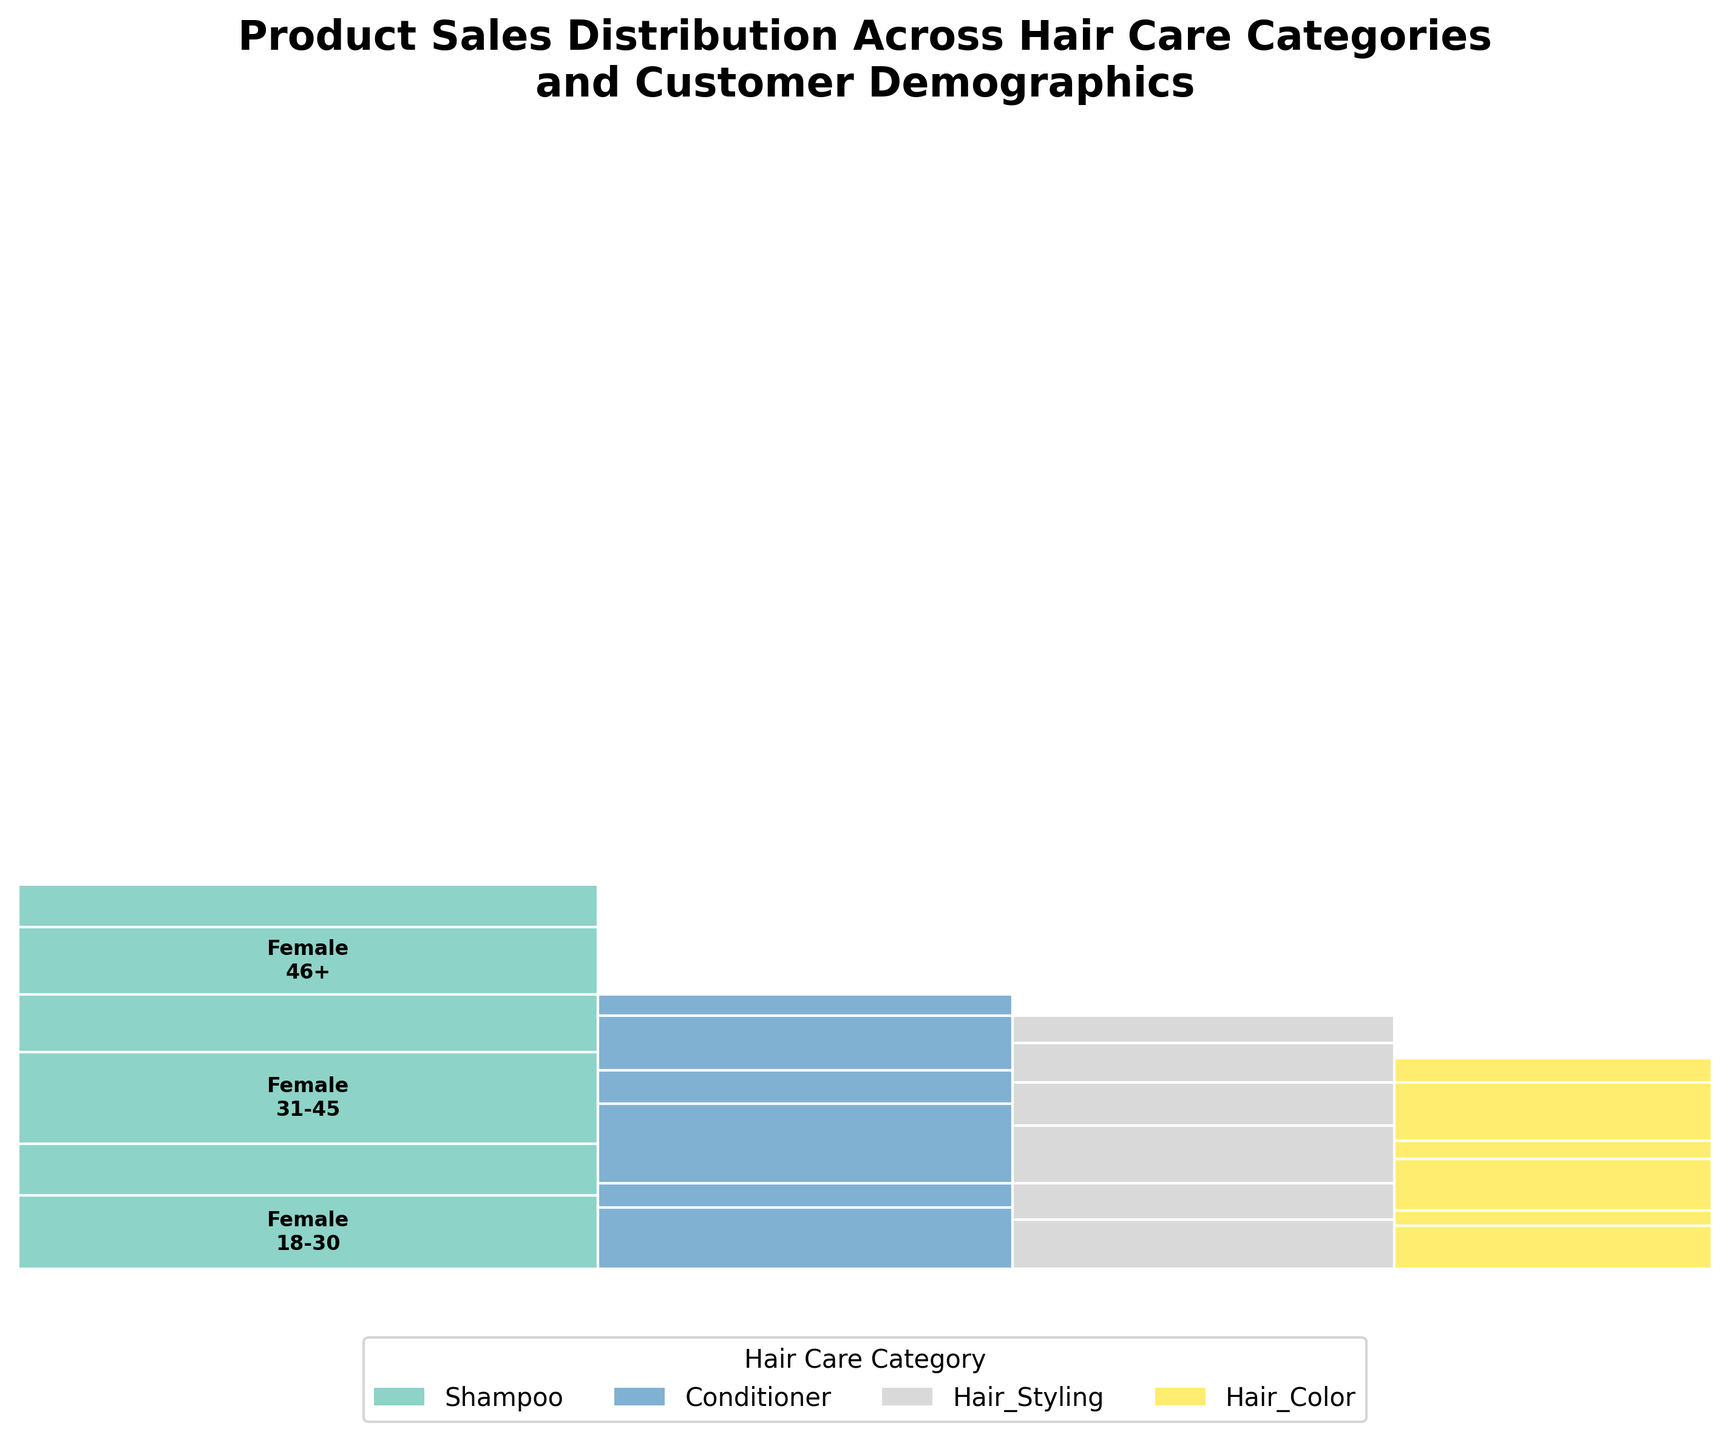What is the title of the plot? The title of the plot is located at the top. It reads "Product Sales Distribution Across Hair Care Categories and Customer Demographics".
Answer: Product Sales Distribution Across Hair Care Categories and Customer Demographics How many hair care categories are displayed in the plot? There are four distinct color-coded sections in the plot, each representing a different hair care category.
Answer: Four Which hair care category has the largest proportion of sales? The width of each category’s section indicates the proportion of overall sales. The largest width belongs to the "Shampoo" category.
Answer: Shampoo Within the Shampoo category, which age and gender group has the highest sales count? Inside the Shampoo section, the largest area corresponds to "31-45, Female". This means this subgroup has the highest sales.
Answer: 31-45, Female Which gender has higher overall sales in the Conditioner category? Within the Conditioner section, comparing the height of regions for females and males in all age groups, we see that female sections are larger in combined height than male sections.
Answer: Female Between Hair Coloring products, which gender in the 46+ age group has more sales? In the Hair Coloring section, comparing the rectangles for males and females in the 46+ group, the female section is taller, indicating higher sales.
Answer: Female What proportion of the plot is covered by Hair Styling products? The section widths proportionally represent sales; summing the fractional widths for Hair Styling gives the proportion. It appears smaller compared to Shampoo and Conditioner, but larger than Hair Color.
Answer: Less than Shampoo and Conditioner, more than Hair Color How do sales for males and females compare in the 18-30 age group across all categories? By summing the vertical portions corresponding to 18-30 males and females in each category, we can visually estimate that females have a larger combined area.
Answer: Females have higher sales Which age group has the most consistent sales across all hair care categories? By comparing the height of age group rectangles within each category, we see the 31-45 group maintains relatively consistent heights over all categories.
Answer: 31-45 For the Hair Coloring category, which age group and gender combination has the lowest sales count? Looking at the Hair Coloring section, the smallest area corresponds to "18-30, Male".
Answer: 18-30, Male 